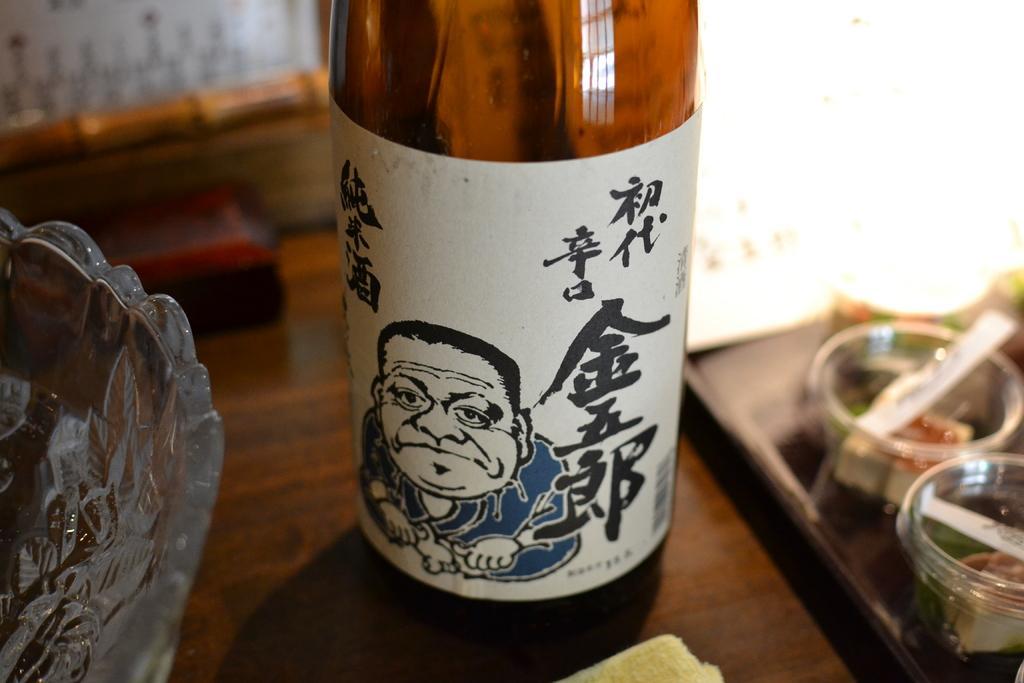Describe this image in one or two sentences. This is bottle, flask and a glass bowl on the table. 